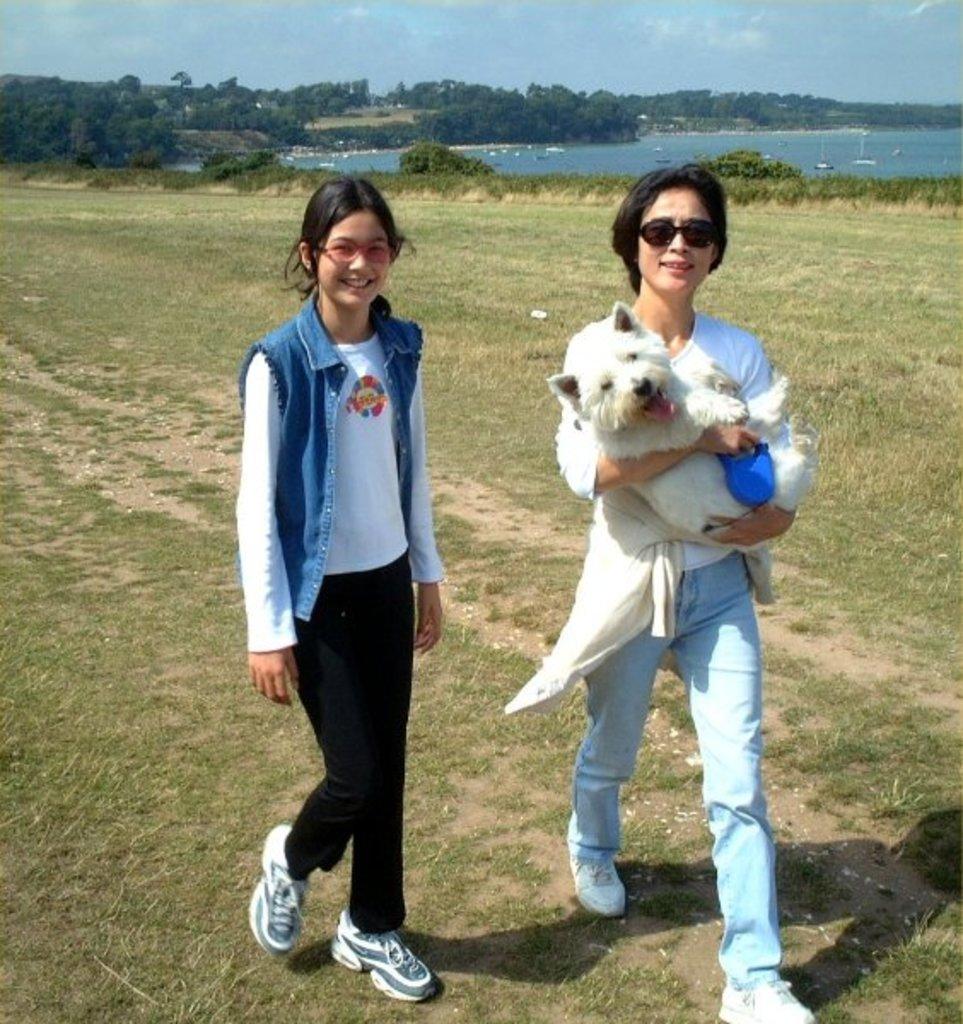In one or two sentences, can you explain what this image depicts? In this image we can see two persons are walking on the ground and one of them is holding a dog with her hands. Here we can see grass. In the background we can see plants, trees, water, and sky with clouds. 